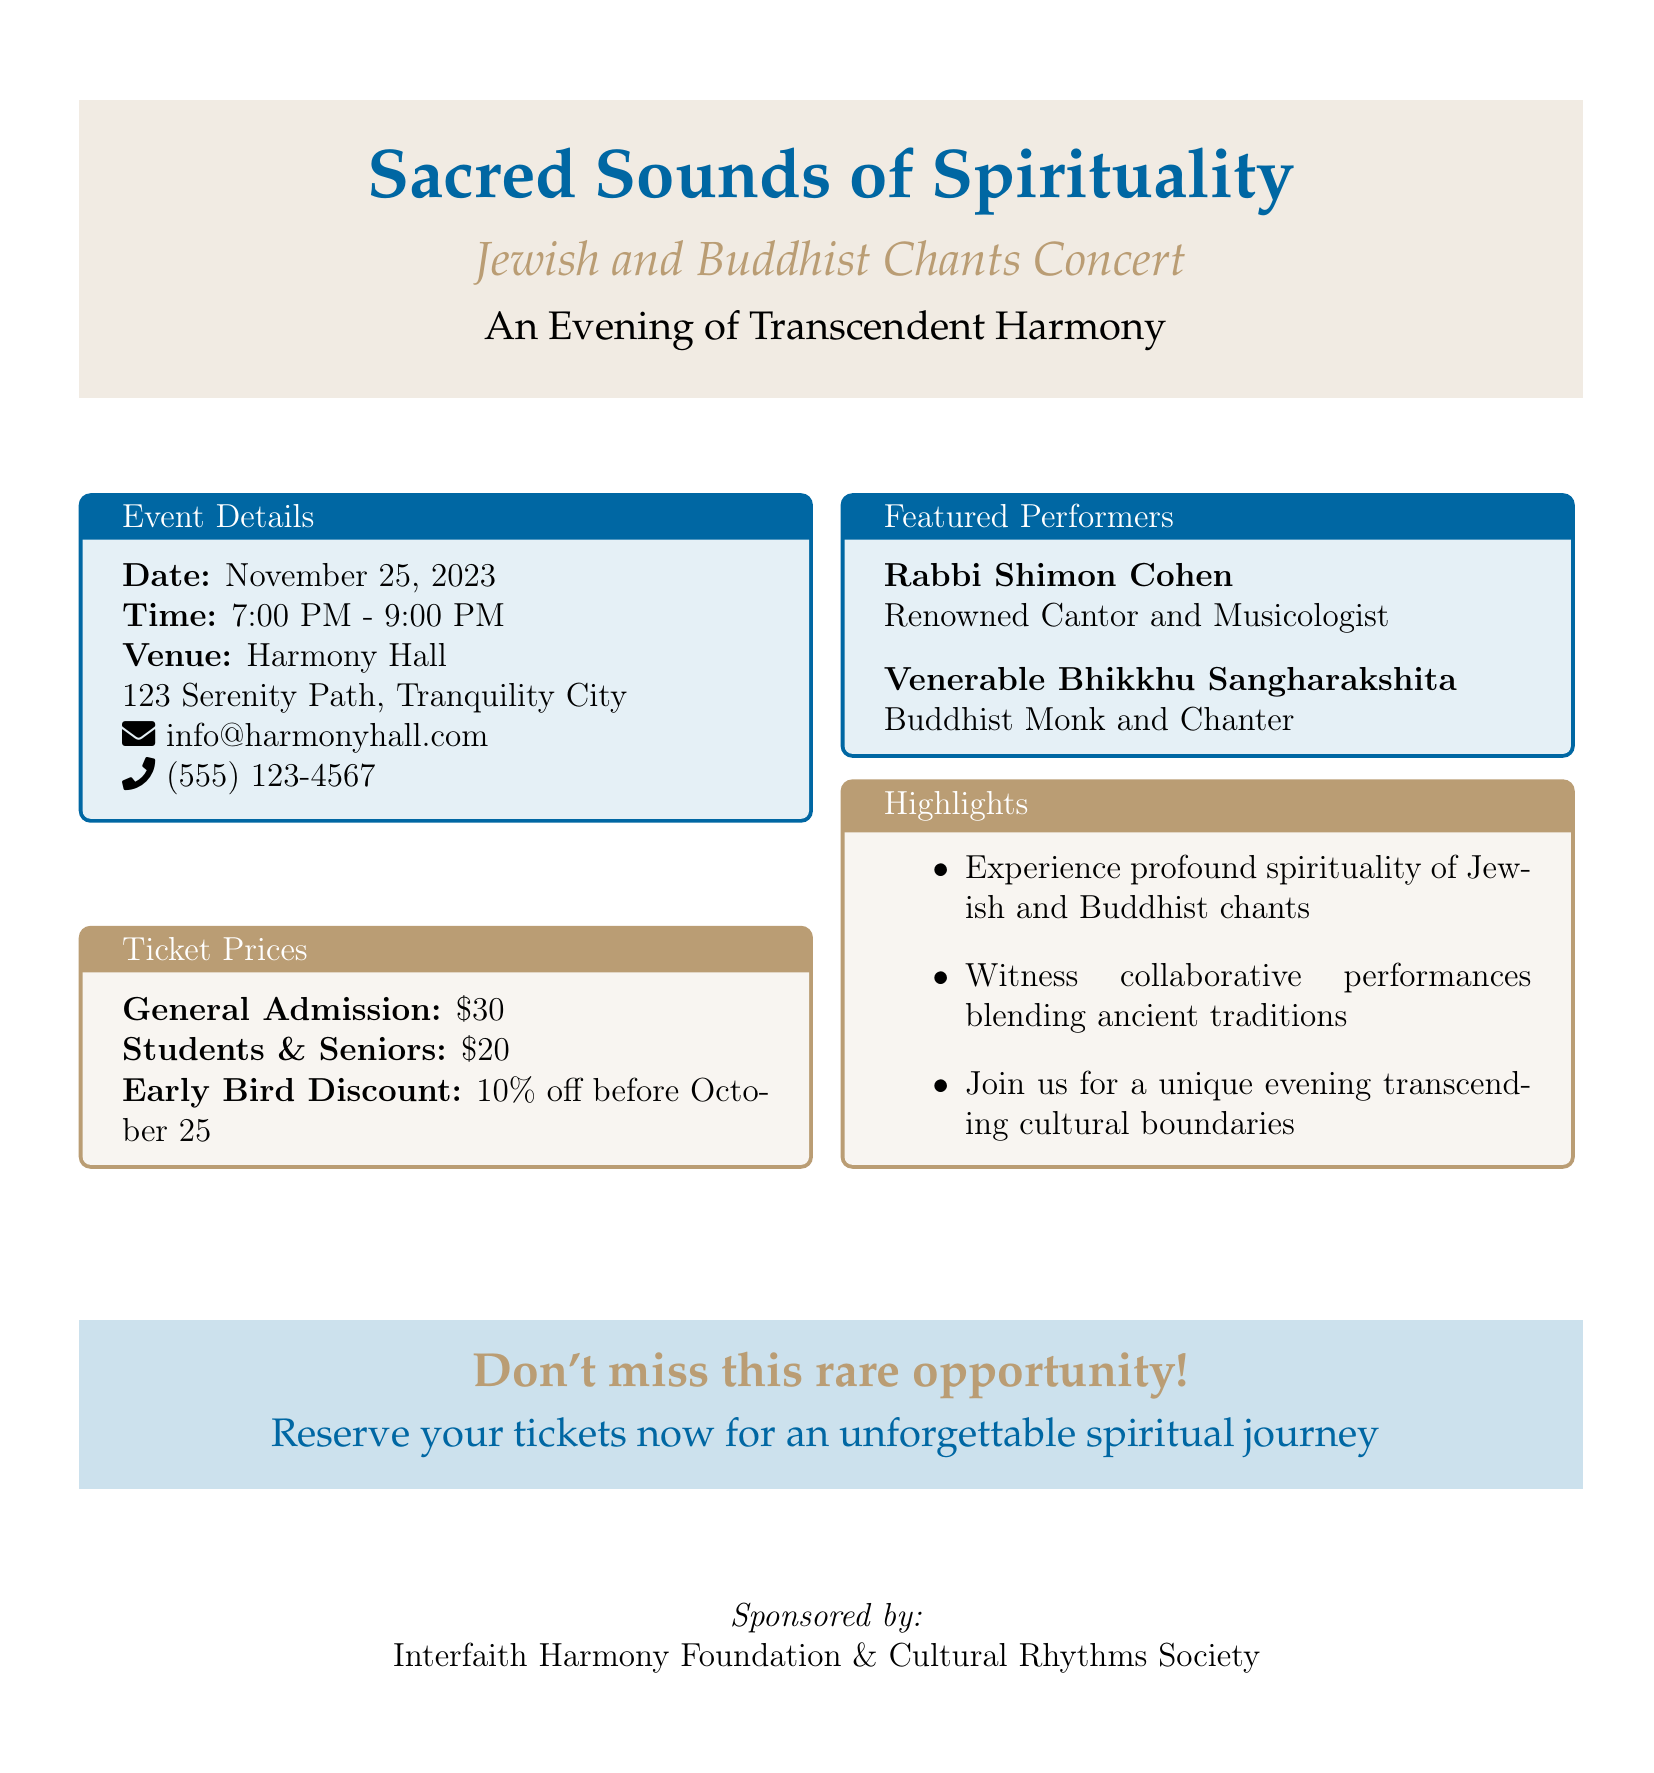What is the date of the concert? The date is clearly stated in the event details section.
Answer: November 25, 2023 What time does the concert start? The start time is included in the event details of the document.
Answer: 7:00 PM Where is the concert being held? The venue information is provided in the event details.
Answer: Harmony Hall What is the ticket price for general admission? The ticket prices are specified in the ticket prices section.
Answer: $30 Who is one of the featured performers? The names of the performers are listed in the featured performers section.
Answer: Rabbi Shimon Cohen What discount is available for early bird tickets? The early bird discount information is included in the ticket prices section.
Answer: 10% off Which organization is sponsoring the event? The sponsor information is mentioned at the bottom of the document.
Answer: Interfaith Harmony Foundation What type of performances will be featured? The highlights section describes the nature of the performances.
Answer: Collaborative performances blending ancient traditions What is the venue's contact email? The contact email is provided in the event details.
Answer: info@harmonyhall.com 